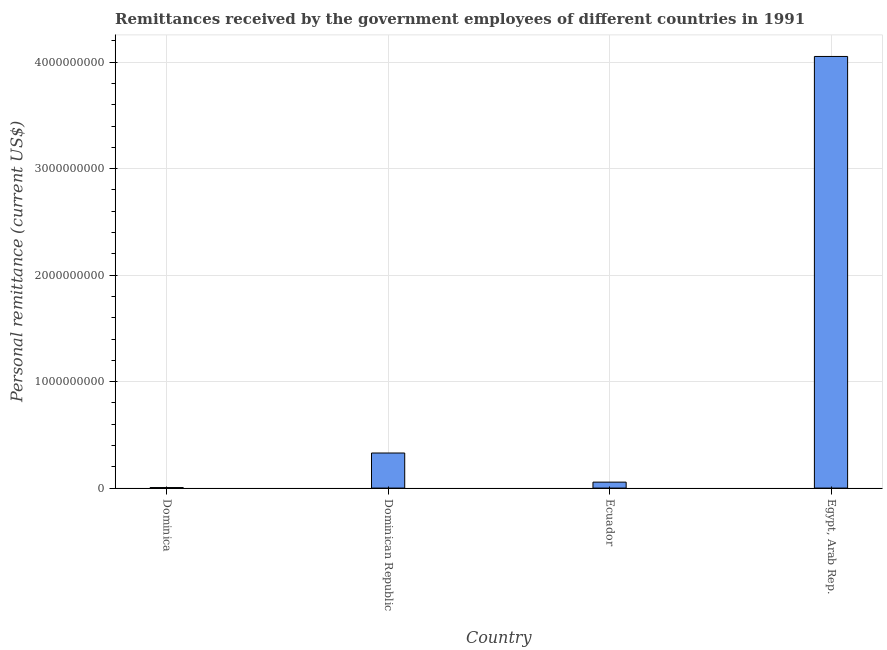Does the graph contain any zero values?
Ensure brevity in your answer.  No. What is the title of the graph?
Provide a succinct answer. Remittances received by the government employees of different countries in 1991. What is the label or title of the Y-axis?
Offer a very short reply. Personal remittance (current US$). What is the personal remittances in Dominica?
Your answer should be very brief. 4.96e+06. Across all countries, what is the maximum personal remittances?
Ensure brevity in your answer.  4.05e+09. Across all countries, what is the minimum personal remittances?
Make the answer very short. 4.96e+06. In which country was the personal remittances maximum?
Your answer should be compact. Egypt, Arab Rep. In which country was the personal remittances minimum?
Provide a succinct answer. Dominica. What is the sum of the personal remittances?
Provide a short and direct response. 4.44e+09. What is the difference between the personal remittances in Dominican Republic and Ecuador?
Your answer should be very brief. 2.74e+08. What is the average personal remittances per country?
Keep it short and to the point. 1.11e+09. What is the median personal remittances?
Make the answer very short. 1.93e+08. What is the ratio of the personal remittances in Dominican Republic to that in Egypt, Arab Rep.?
Offer a very short reply. 0.08. What is the difference between the highest and the second highest personal remittances?
Offer a terse response. 3.72e+09. What is the difference between the highest and the lowest personal remittances?
Make the answer very short. 4.05e+09. Are all the bars in the graph horizontal?
Give a very brief answer. No. How many countries are there in the graph?
Offer a very short reply. 4. What is the difference between two consecutive major ticks on the Y-axis?
Give a very brief answer. 1.00e+09. What is the Personal remittance (current US$) of Dominica?
Your answer should be very brief. 4.96e+06. What is the Personal remittance (current US$) in Dominican Republic?
Give a very brief answer. 3.30e+08. What is the Personal remittance (current US$) of Ecuador?
Your answer should be very brief. 5.60e+07. What is the Personal remittance (current US$) in Egypt, Arab Rep.?
Your response must be concise. 4.05e+09. What is the difference between the Personal remittance (current US$) in Dominica and Dominican Republic?
Make the answer very short. -3.25e+08. What is the difference between the Personal remittance (current US$) in Dominica and Ecuador?
Your response must be concise. -5.10e+07. What is the difference between the Personal remittance (current US$) in Dominica and Egypt, Arab Rep.?
Offer a terse response. -4.05e+09. What is the difference between the Personal remittance (current US$) in Dominican Republic and Ecuador?
Your answer should be very brief. 2.74e+08. What is the difference between the Personal remittance (current US$) in Dominican Republic and Egypt, Arab Rep.?
Your answer should be very brief. -3.72e+09. What is the difference between the Personal remittance (current US$) in Ecuador and Egypt, Arab Rep.?
Provide a succinct answer. -4.00e+09. What is the ratio of the Personal remittance (current US$) in Dominica to that in Dominican Republic?
Offer a very short reply. 0.01. What is the ratio of the Personal remittance (current US$) in Dominica to that in Ecuador?
Give a very brief answer. 0.09. What is the ratio of the Personal remittance (current US$) in Dominica to that in Egypt, Arab Rep.?
Provide a short and direct response. 0. What is the ratio of the Personal remittance (current US$) in Dominican Republic to that in Ecuador?
Make the answer very short. 5.88. What is the ratio of the Personal remittance (current US$) in Dominican Republic to that in Egypt, Arab Rep.?
Your answer should be compact. 0.08. What is the ratio of the Personal remittance (current US$) in Ecuador to that in Egypt, Arab Rep.?
Ensure brevity in your answer.  0.01. 